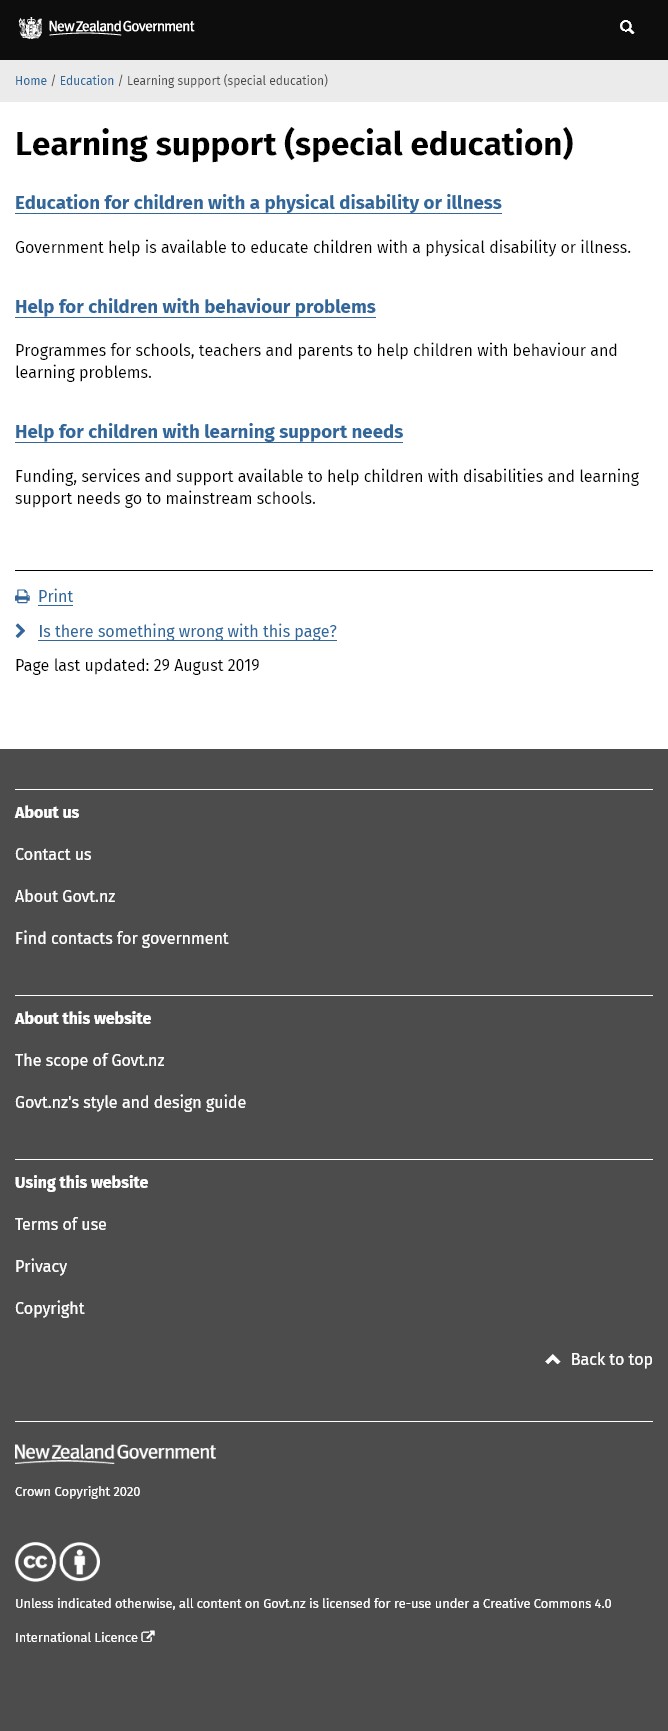Give some essential details in this illustration. I, [your name], hereby declare that funding, services, and support for children with disabilities and learning support needs go directly to mainstream schools, rather than being directed towards special needs schools or other dedicated facilities. It is important to note that children who experience certain conditions, such as physical disabilities or illnesses, behavioral problems, or learning support needs, may be eligible for learning support services. There are programs available for schools, teachers, and parents to assist children with behavior and learning difficulties. 